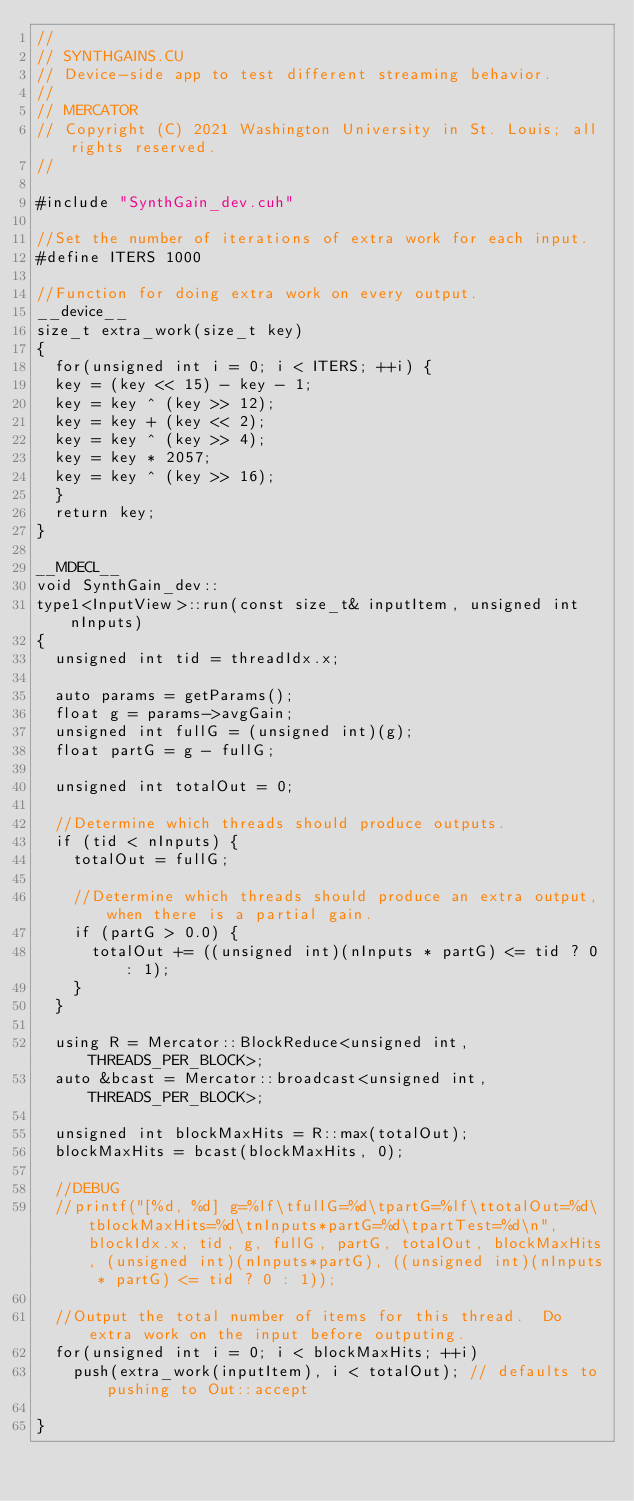<code> <loc_0><loc_0><loc_500><loc_500><_Cuda_>//
// SYNTHGAINS.CU
// Device-side app to test different streaming behavior.
//
// MERCATOR
// Copyright (C) 2021 Washington University in St. Louis; all rights reserved.
//

#include "SynthGain_dev.cuh"

//Set the number of iterations of extra work for each input.
#define ITERS 1000

//Function for doing extra work on every output.
__device__
size_t extra_work(size_t key)
{
  for(unsigned int i = 0; i < ITERS; ++i) {
  key = (key << 15) - key - 1;
  key = key ^ (key >> 12);
  key = key + (key << 2);
  key = key ^ (key >> 4);
  key = key * 2057;
  key = key ^ (key >> 16);
  }
  return key;
}

__MDECL__
void SynthGain_dev::
type1<InputView>::run(const size_t& inputItem, unsigned int nInputs)
{
  unsigned int tid = threadIdx.x;

  auto params = getParams();
  float g = params->avgGain;
  unsigned int fullG = (unsigned int)(g);
  float partG = g - fullG;

  unsigned int totalOut = 0;
  
  //Determine which threads should produce outputs.
  if (tid < nInputs) {
    totalOut = fullG;

    //Determine which threads should produce an extra output, when there is a partial gain.
    if (partG > 0.0) {
      totalOut += ((unsigned int)(nInputs * partG) <= tid ? 0 : 1);
    }
  }

  using R = Mercator::BlockReduce<unsigned int, THREADS_PER_BLOCK>;
  auto &bcast = Mercator::broadcast<unsigned int, THREADS_PER_BLOCK>;
  
  unsigned int blockMaxHits = R::max(totalOut);
  blockMaxHits = bcast(blockMaxHits, 0);

  //DEBUG
  //printf("[%d, %d] g=%lf\tfullG=%d\tpartG=%lf\ttotalOut=%d\tblockMaxHits=%d\tnInputs*partG=%d\tpartTest=%d\n", blockIdx.x, tid, g, fullG, partG, totalOut, blockMaxHits, (unsigned int)(nInputs*partG), ((unsigned int)(nInputs * partG) <= tid ? 0 : 1));

  //Output the total number of items for this thread.  Do extra work on the input before outputing.
  for(unsigned int i = 0; i < blockMaxHits; ++i)
    push(extra_work(inputItem), i < totalOut); // defaults to pushing to Out::accept

}

</code> 